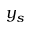<formula> <loc_0><loc_0><loc_500><loc_500>y _ { s }</formula> 